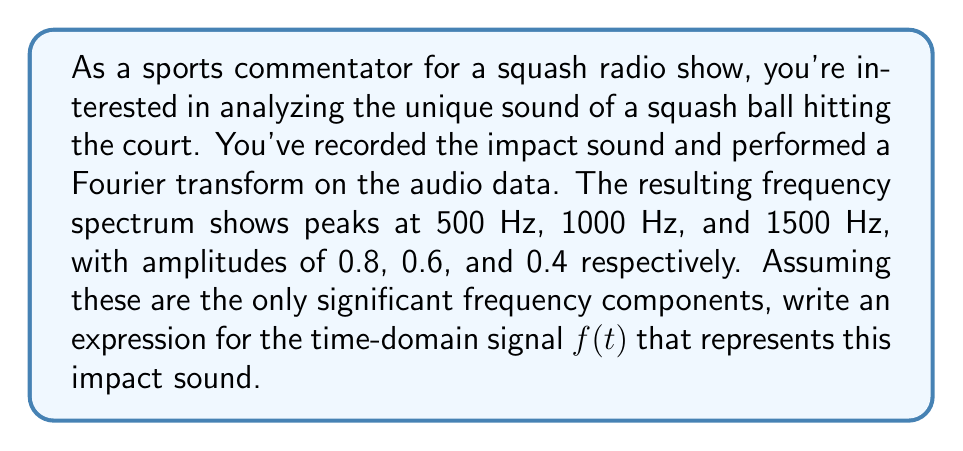Provide a solution to this math problem. To solve this problem, we need to use the inverse Fourier transform to convert the frequency domain information into a time-domain signal. Here's a step-by-step approach:

1) The general form of a signal with discrete frequency components is:

   $$f(t) = \sum_{n=1}^N A_n \cos(2\pi f_n t + \phi_n)$$

   Where $A_n$ is the amplitude, $f_n$ is the frequency, and $\phi_n$ is the phase of each component.

2) We have three frequency components:
   - 500 Hz with amplitude 0.8
   - 1000 Hz with amplitude 0.6
   - 1500 Hz with amplitude 0.4

3) Since we don't have phase information, we can assume all phases are zero for simplicity. This gives us:

   $$f(t) = 0.8 \cos(2\pi \cdot 500t) + 0.6 \cos(2\pi \cdot 1000t) + 0.4 \cos(2\pi \cdot 1500t)$$

4) Simplify by factoring out $2\pi$:

   $$f(t) = 0.8 \cos(1000\pi t) + 0.6 \cos(2000\pi t) + 0.4 \cos(3000\pi t)$$

This expression represents the time-domain signal of the squash ball's impact sound based on the given frequency components.
Answer: $$f(t) = 0.8 \cos(1000\pi t) + 0.6 \cos(2000\pi t) + 0.4 \cos(3000\pi t)$$ 